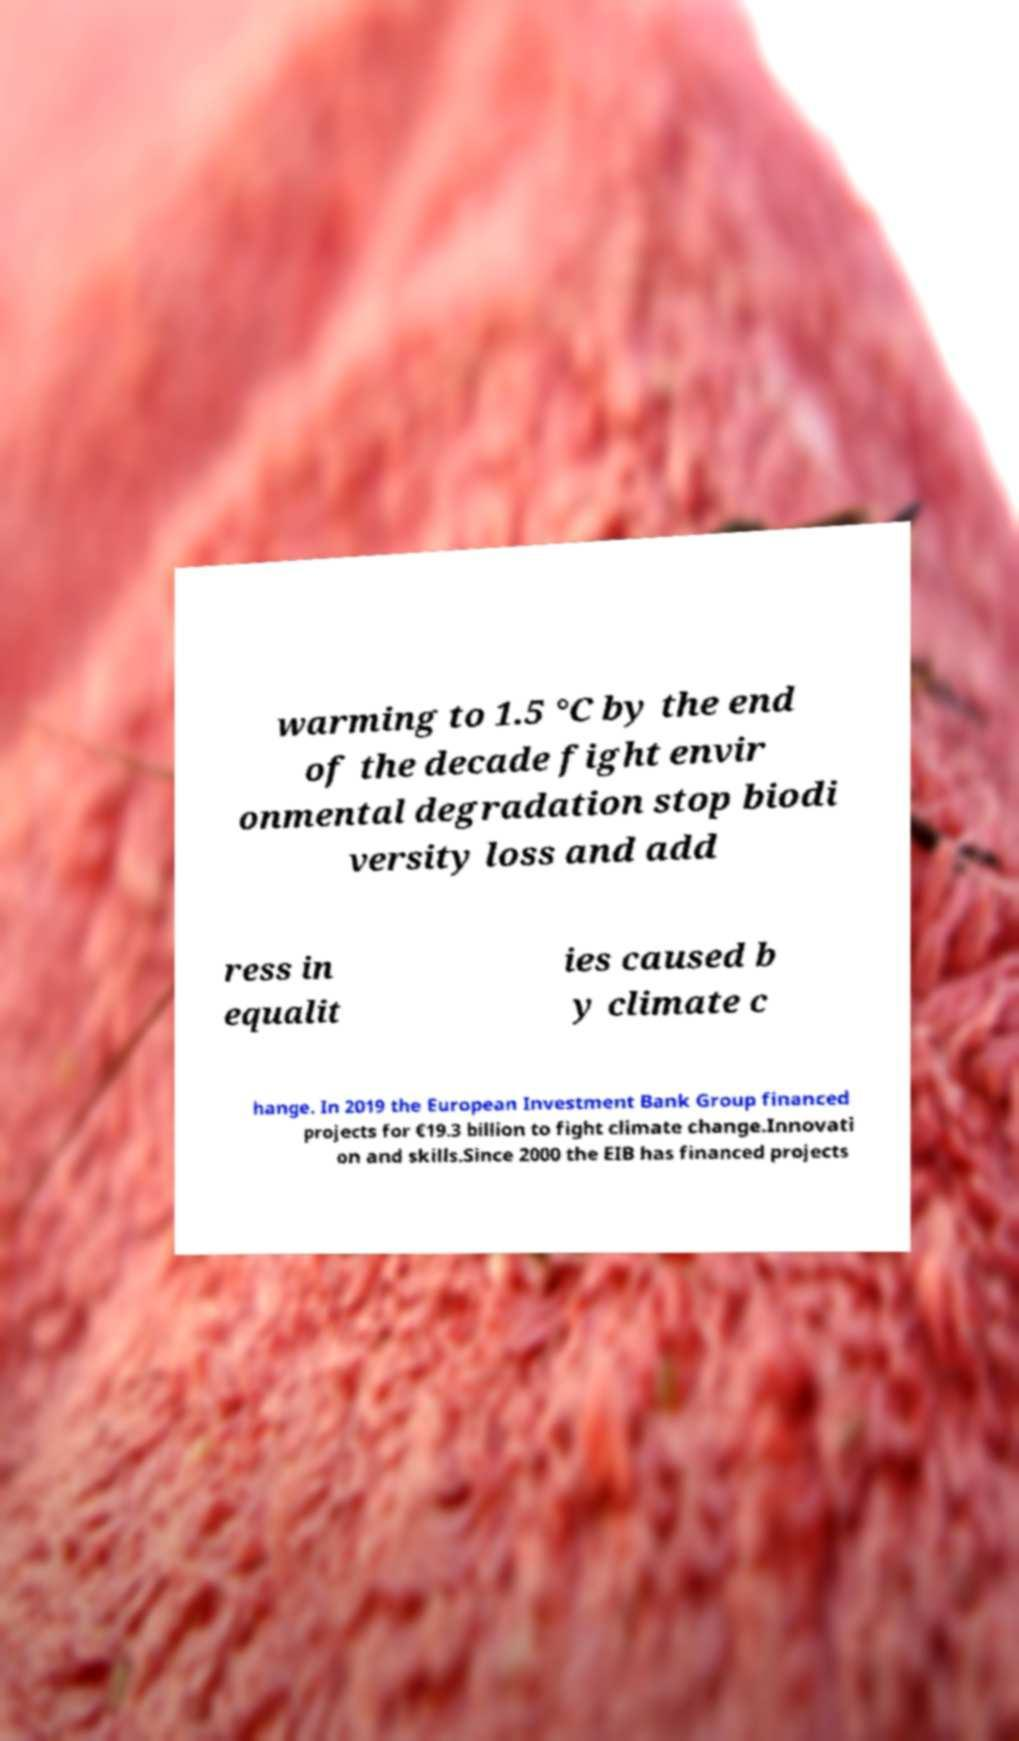I need the written content from this picture converted into text. Can you do that? warming to 1.5 °C by the end of the decade fight envir onmental degradation stop biodi versity loss and add ress in equalit ies caused b y climate c hange. In 2019 the European Investment Bank Group financed projects for €19.3 billion to fight climate change.Innovati on and skills.Since 2000 the EIB has financed projects 